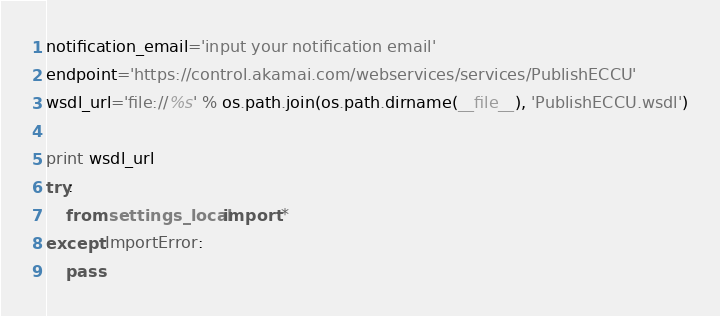<code> <loc_0><loc_0><loc_500><loc_500><_Python_>notification_email='input your notification email'
endpoint='https://control.akamai.com/webservices/services/PublishECCU'
wsdl_url='file://%s' % os.path.join(os.path.dirname(__file__), 'PublishECCU.wsdl')

print wsdl_url
try:
    from settings_local import *
except ImportError:
    pass
</code> 